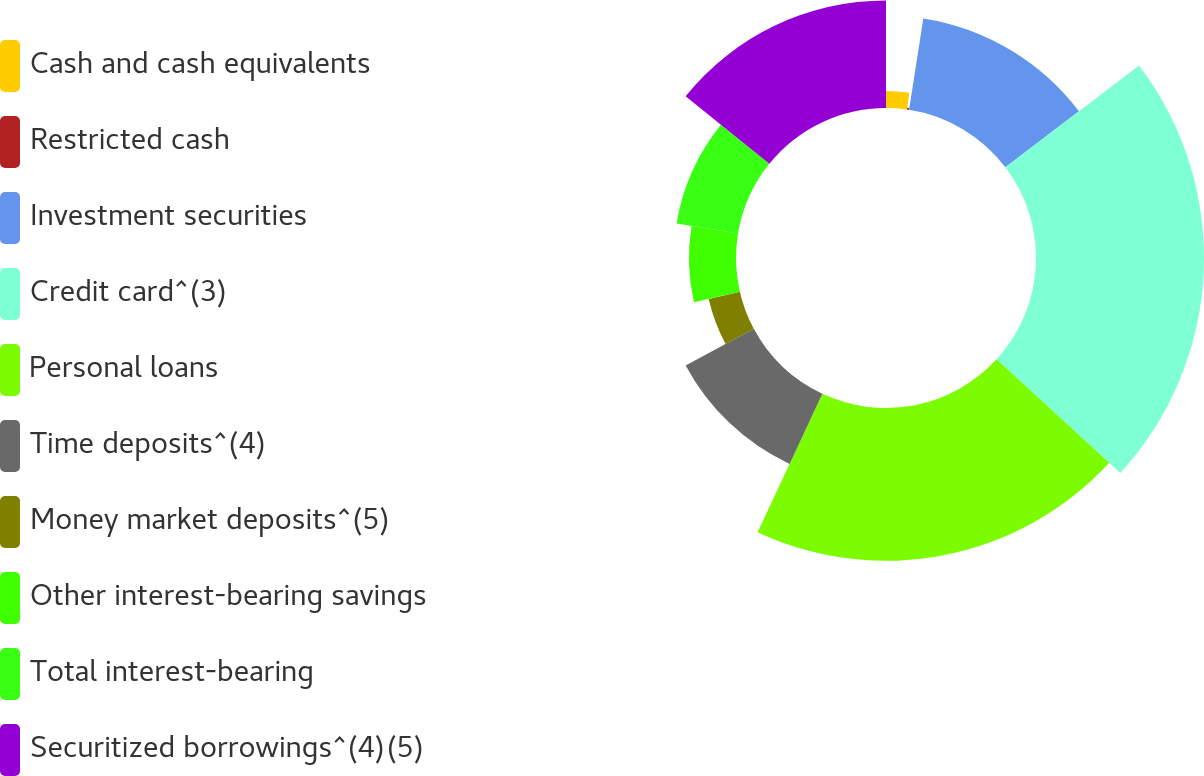<chart> <loc_0><loc_0><loc_500><loc_500><pie_chart><fcel>Cash and cash equivalents<fcel>Restricted cash<fcel>Investment securities<fcel>Credit card^(3)<fcel>Personal loans<fcel>Time deposits^(4)<fcel>Money market deposits^(5)<fcel>Other interest-bearing savings<fcel>Total interest-bearing<fcel>Securitized borrowings^(4)(5)<nl><fcel>2.23%<fcel>0.23%<fcel>12.19%<fcel>22.16%<fcel>20.16%<fcel>10.2%<fcel>4.22%<fcel>6.21%<fcel>8.21%<fcel>14.19%<nl></chart> 